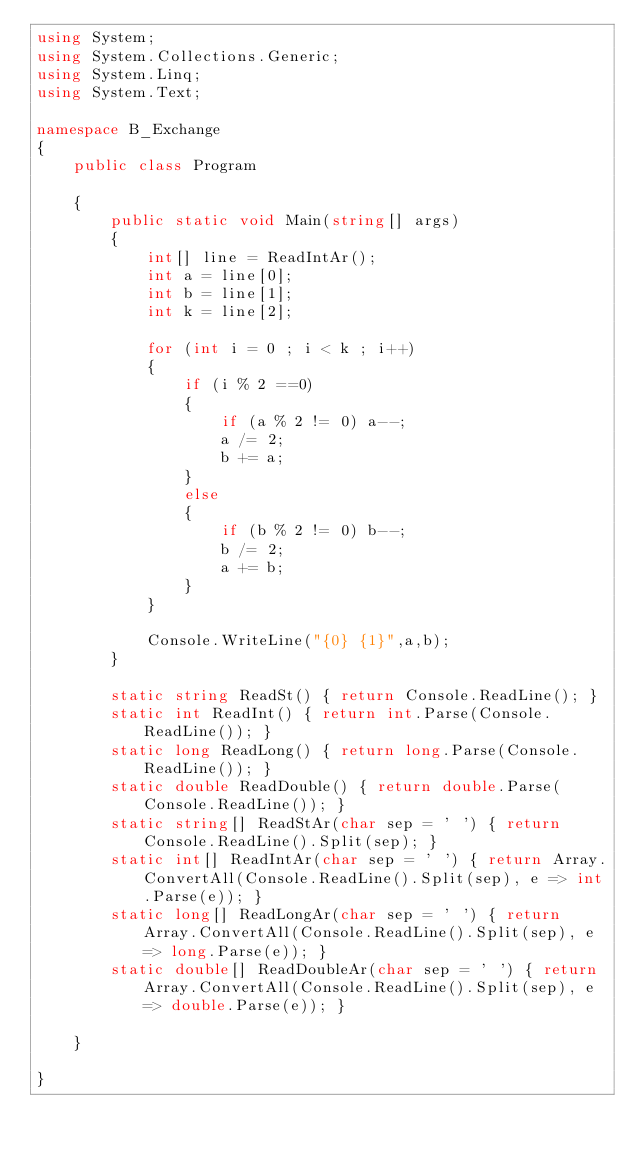Convert code to text. <code><loc_0><loc_0><loc_500><loc_500><_C#_>using System;
using System.Collections.Generic;
using System.Linq;
using System.Text;

namespace B_Exchange
{
    public class Program

    {
        public static void Main(string[] args)
        {
            int[] line = ReadIntAr();
            int a = line[0];
            int b = line[1];
            int k = line[2];

            for (int i = 0 ; i < k ; i++)
            {
                if (i % 2 ==0)
                {
                    if (a % 2 != 0) a--;
                    a /= 2;
                    b += a;
                }
                else
                {
                    if (b % 2 != 0) b--;
                    b /= 2;
                    a += b;
                }
            }

            Console.WriteLine("{0} {1}",a,b);
        }

        static string ReadSt() { return Console.ReadLine(); }
        static int ReadInt() { return int.Parse(Console.ReadLine()); }
        static long ReadLong() { return long.Parse(Console.ReadLine()); }
        static double ReadDouble() { return double.Parse(Console.ReadLine()); }
        static string[] ReadStAr(char sep = ' ') { return Console.ReadLine().Split(sep); }
        static int[] ReadIntAr(char sep = ' ') { return Array.ConvertAll(Console.ReadLine().Split(sep), e => int.Parse(e)); }
        static long[] ReadLongAr(char sep = ' ') { return Array.ConvertAll(Console.ReadLine().Split(sep), e => long.Parse(e)); }
        static double[] ReadDoubleAr(char sep = ' ') { return Array.ConvertAll(Console.ReadLine().Split(sep), e => double.Parse(e)); }

    }

}
</code> 